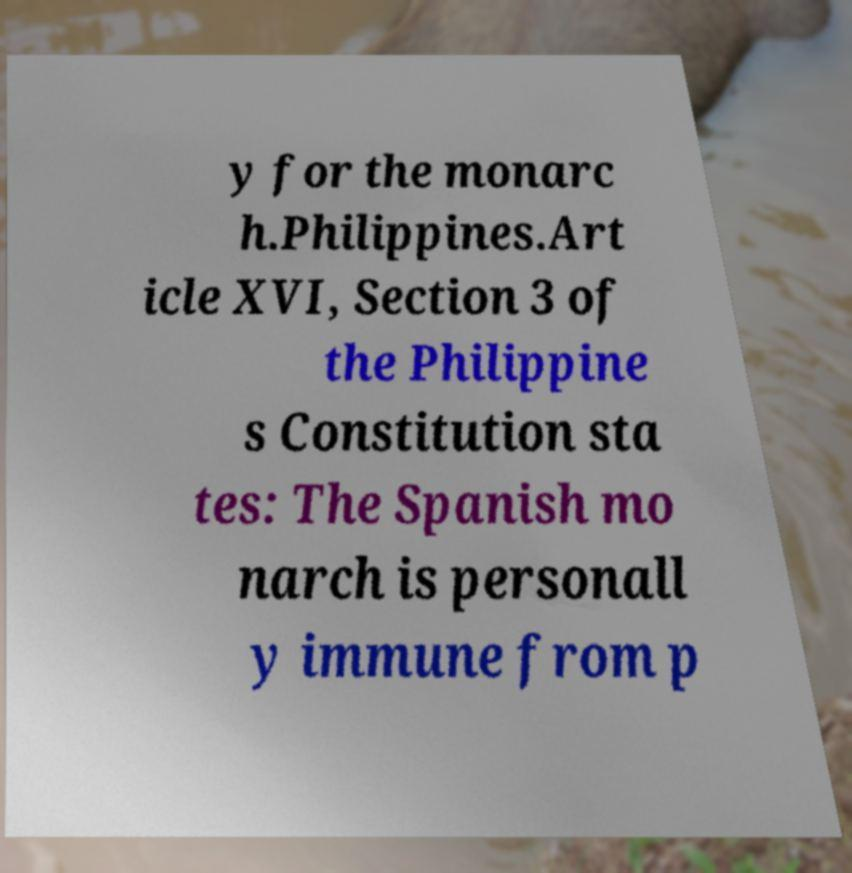There's text embedded in this image that I need extracted. Can you transcribe it verbatim? y for the monarc h.Philippines.Art icle XVI, Section 3 of the Philippine s Constitution sta tes: The Spanish mo narch is personall y immune from p 